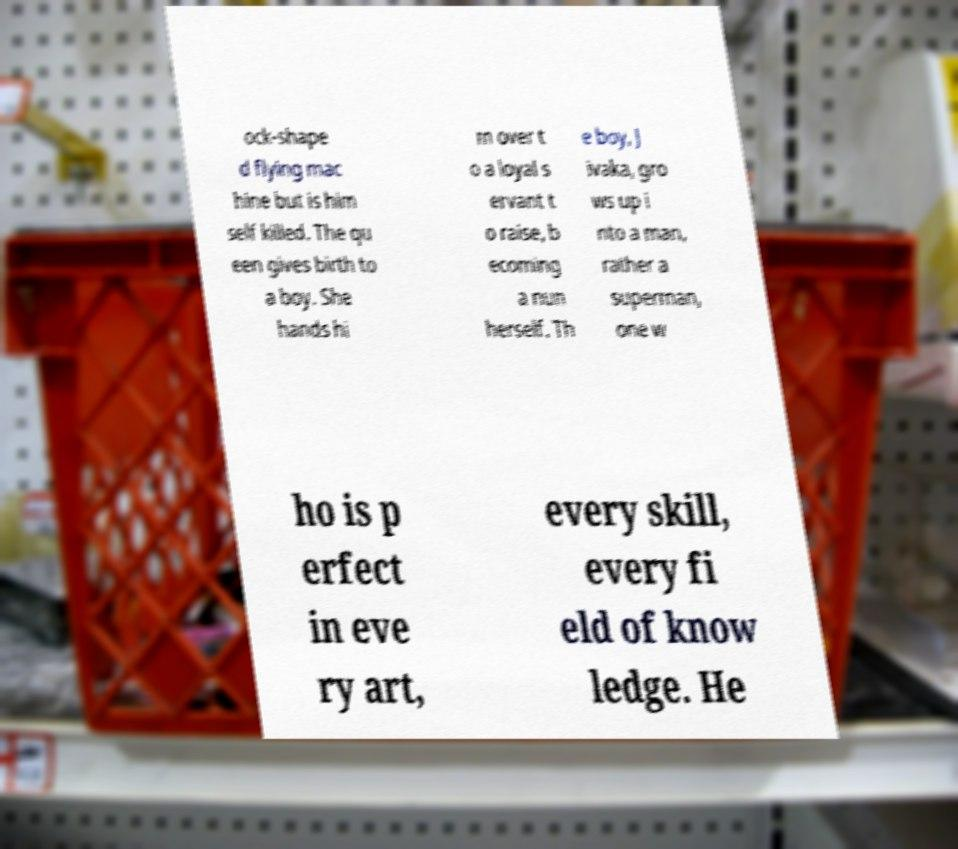Can you accurately transcribe the text from the provided image for me? ock-shape d flying mac hine but is him self killed. The qu een gives birth to a boy. She hands hi m over t o a loyal s ervant t o raise, b ecoming a nun herself. Th e boy, J ivaka, gro ws up i nto a man, rather a superman, one w ho is p erfect in eve ry art, every skill, every fi eld of know ledge. He 